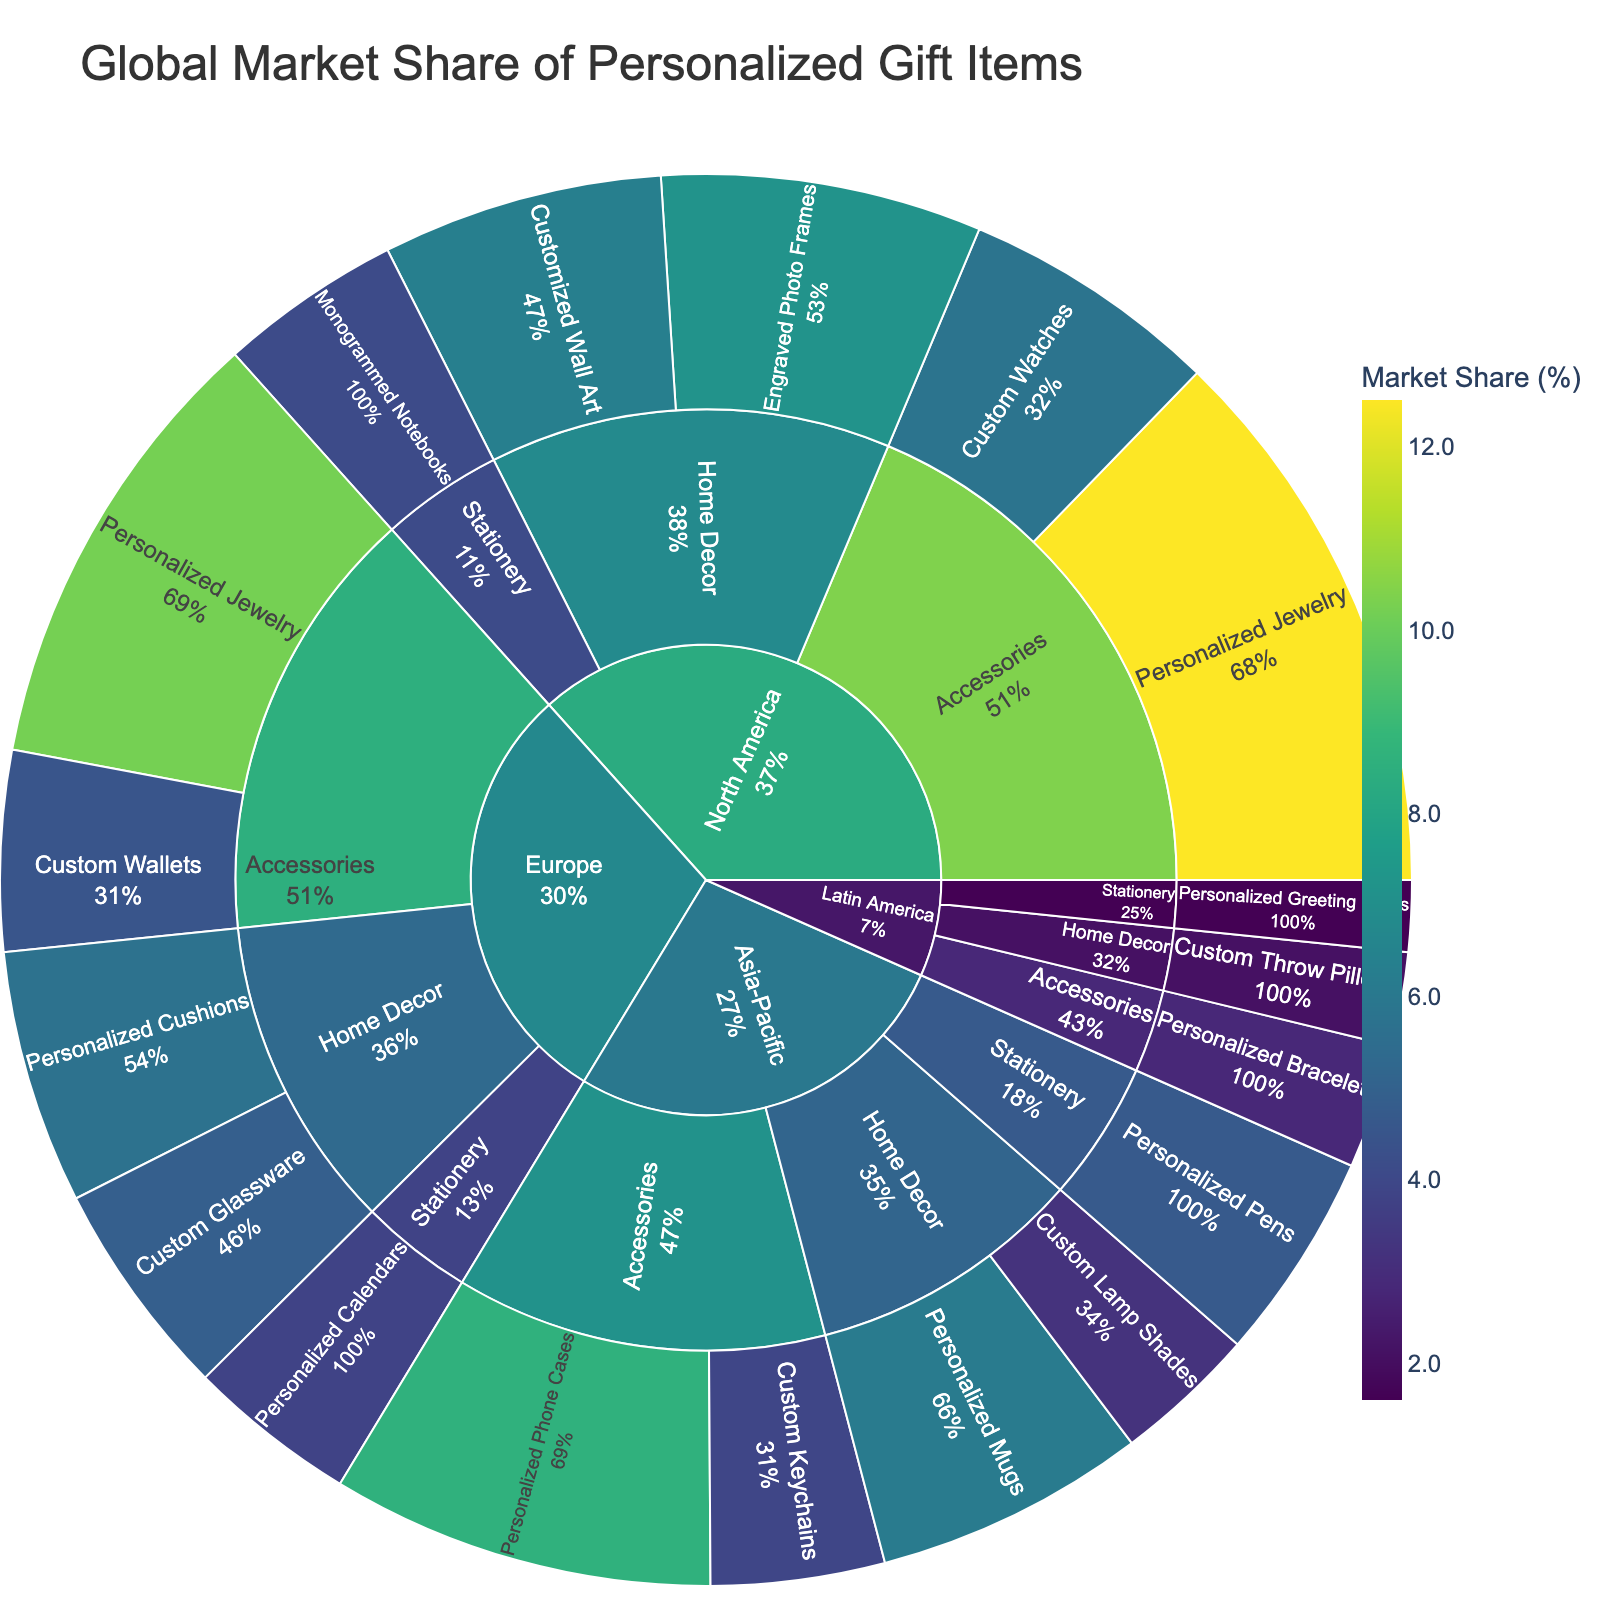What is the title of the figure? The title can be found at the top of the figure. It provides an overview of what the plot is about. In this case, the title is "Global Market Share of Personalized Gift Items" which means the figure displays the market share distribution of various personalized gift items across different regions.
Answer: Global Market Share of Personalized Gift Items Which category in North America has the highest market share? To determine which category in North America has the highest market share, we look for the region "North America," then check the sub-categories under it. Among Accessories, Home Decor, and Stationery, Accessories has the largest combined market share (12.5 + 5.8).
Answer: Accessories What is the combined market share of Personalized Jewelry from all regions? To find the total market share of Personalized Jewelry, we add the market shares from North America (12.5%) and Europe (10.2%). This results in 12.5 + 10.2 = 22.7%.
Answer: 22.7% Which region has the lowest market share product and what is it? To find this, we identify the lowest market share product value from all regions and categories. "Personalized Greeting Cards" in Latin America has the lowest market share of 1.6%.
Answer: Latin America, Personalized Greeting Cards Compare the market share of Home Decor in North America and Asia-Pacific. Which has the higher market share and by how much? First, we sum the market shares of all Home Decor products in North America (7.2 + 6.3 = 13.5%) and Asia-Pacific (6.1 + 3.2 = 9.3%). North America has a higher market share. The difference is 13.5% - 9.3% = 4.2%.
Answer: North America, 4.2% What percentage of total market share does Europe contribute to Accessories? We add the market shares of Accessories in Europe: Personalized Jewelry (10.2%) + Custom Wallets (4.5%) = 14.7%. This is the total percentage contributed by Europe in the Accessories category.
Answer: 14.7% Is the market share of Monogrammed Notebooks higher than Personalized Cushions? By how much? We compare the market share values of Monogrammed Notebooks in North America (4.1%) with Personalized Cushions in Europe (5.7%). Personalized Cushions has a higher market share. The difference is 5.7% - 4.1% = 1.6%.
Answer: No, 1.6% How does the market share of Personalized Phone Cases in Asia-Pacific compare with Personalized Jewelry in Europe? The market shares are Personalized Phone Cases (8.6%) in Asia-Pacific and Personalized Jewelry (10.2%) in Europe. Personalized Jewelry in Europe has a higher market share.
Answer: Personalized Jewelry in Europe Which product in the Accessories category has the highest combined market share across all regions? To find the product with the highest combined market share in the Accessories category, we compare the sum of the individual market shares of each product across all regions. Personalized Jewelry (12.5 North America + 10.2 Europe = 22.7%) is the highest.
Answer: Personalized Jewelry How much higher is the market share of Engraved Photo Frames compared to Custom Watches in North America? The market share of Engraved Photo Frames (7.2%) should be compared with Custom Watches (5.8%) in North America. The difference is 7.2% - 5.8% = 1.4%.
Answer: 1.4% 